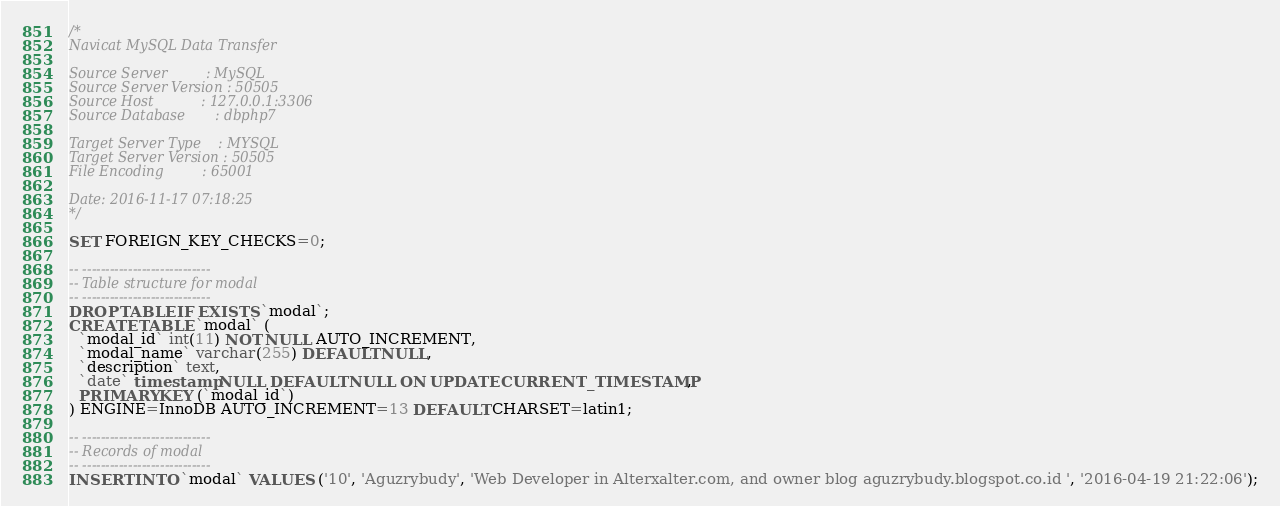<code> <loc_0><loc_0><loc_500><loc_500><_SQL_>/*
Navicat MySQL Data Transfer

Source Server         : MySQL
Source Server Version : 50505
Source Host           : 127.0.0.1:3306
Source Database       : dbphp7

Target Server Type    : MYSQL
Target Server Version : 50505
File Encoding         : 65001

Date: 2016-11-17 07:18:25
*/

SET FOREIGN_KEY_CHECKS=0;

-- ----------------------------
-- Table structure for modal
-- ----------------------------
DROP TABLE IF EXISTS `modal`;
CREATE TABLE `modal` (
  `modal_id` int(11) NOT NULL AUTO_INCREMENT,
  `modal_name` varchar(255) DEFAULT NULL,
  `description` text,
  `date` timestamp NULL DEFAULT NULL ON UPDATE CURRENT_TIMESTAMP,
  PRIMARY KEY (`modal_id`)
) ENGINE=InnoDB AUTO_INCREMENT=13 DEFAULT CHARSET=latin1;

-- ----------------------------
-- Records of modal
-- ----------------------------
INSERT INTO `modal` VALUES ('10', 'Aguzrybudy', 'Web Developer in Alterxalter.com, and owner blog aguzrybudy.blogspot.co.id ', '2016-04-19 21:22:06');</code> 